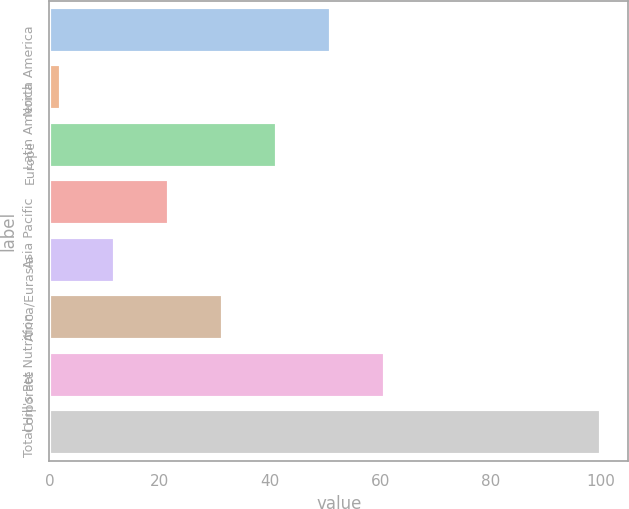Convert chart. <chart><loc_0><loc_0><loc_500><loc_500><bar_chart><fcel>North America<fcel>Latin America<fcel>Europe<fcel>Asia Pacific<fcel>Africa/Eurasia<fcel>Hill's Pet Nutrition<fcel>Corporate<fcel>Total<nl><fcel>51<fcel>2<fcel>41.2<fcel>21.6<fcel>11.8<fcel>31.4<fcel>60.8<fcel>100<nl></chart> 